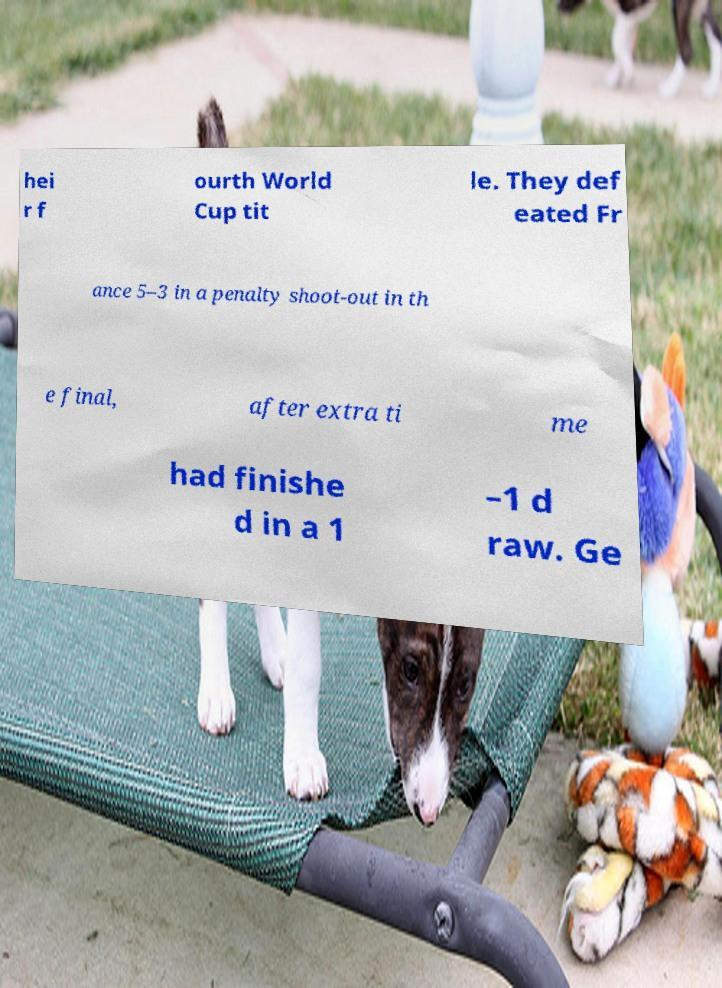Can you accurately transcribe the text from the provided image for me? hei r f ourth World Cup tit le. They def eated Fr ance 5–3 in a penalty shoot-out in th e final, after extra ti me had finishe d in a 1 –1 d raw. Ge 